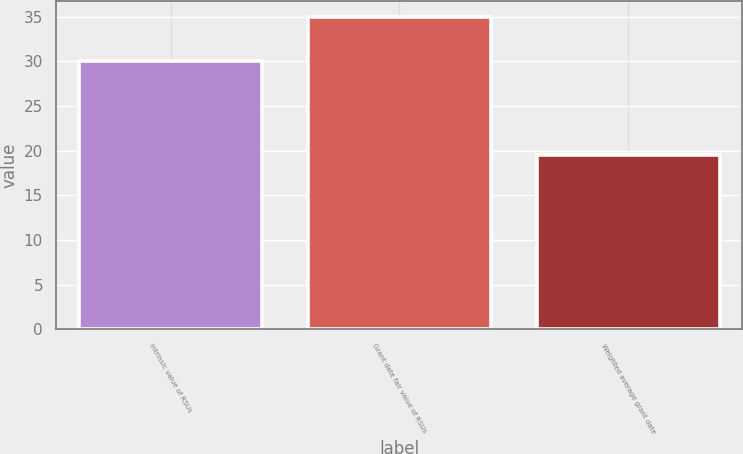Convert chart. <chart><loc_0><loc_0><loc_500><loc_500><bar_chart><fcel>Intrinsic value of RSUs<fcel>Grant date fair value of RSUs<fcel>Weighted average grant date<nl><fcel>30<fcel>35<fcel>19.57<nl></chart> 